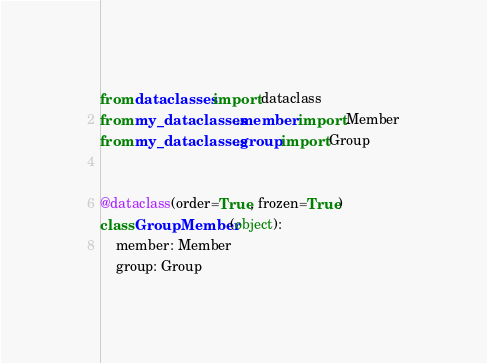Convert code to text. <code><loc_0><loc_0><loc_500><loc_500><_Python_>from dataclasses import dataclass
from my_dataclasses.member import Member
from my_dataclasses.group import Group


@dataclass(order=True, frozen=True)
class GroupMember(object):
    member: Member
    group: Group
</code> 